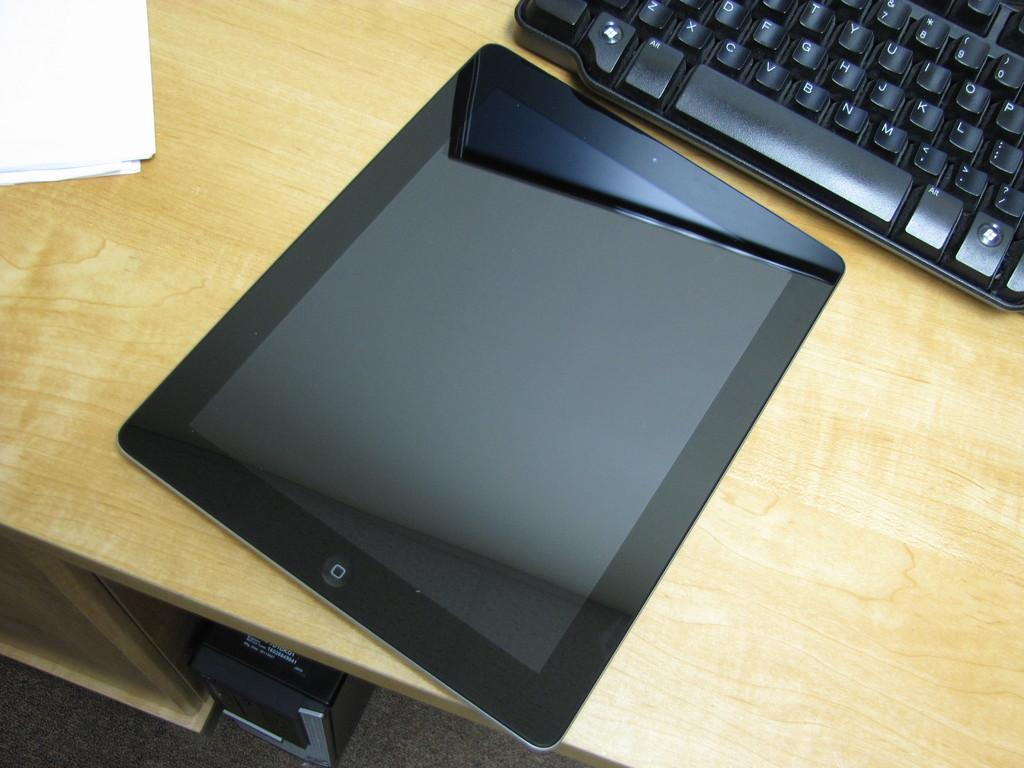<image>
Write a terse but informative summary of the picture. A notebook and laptop on a desk with a keyboard showing the ALT key 